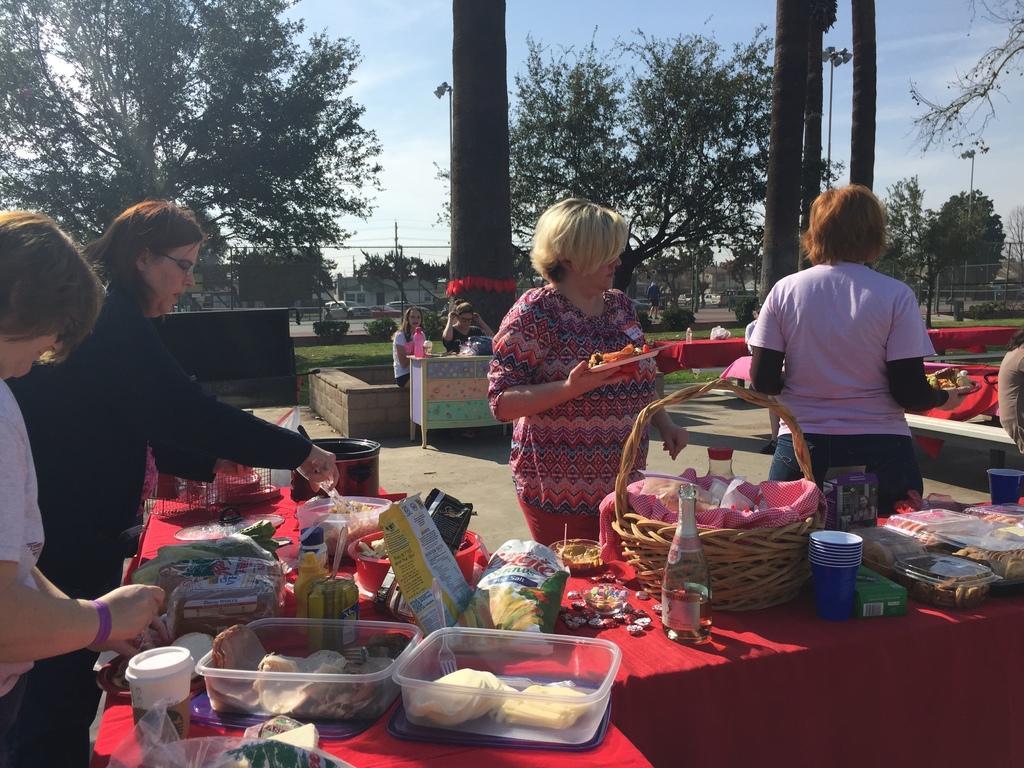Could you give a brief overview of what you see in this image? In this picture I can observe some women. I can observe red color table on which there is some food and bottles are placed. In the background there are trees and sky. 